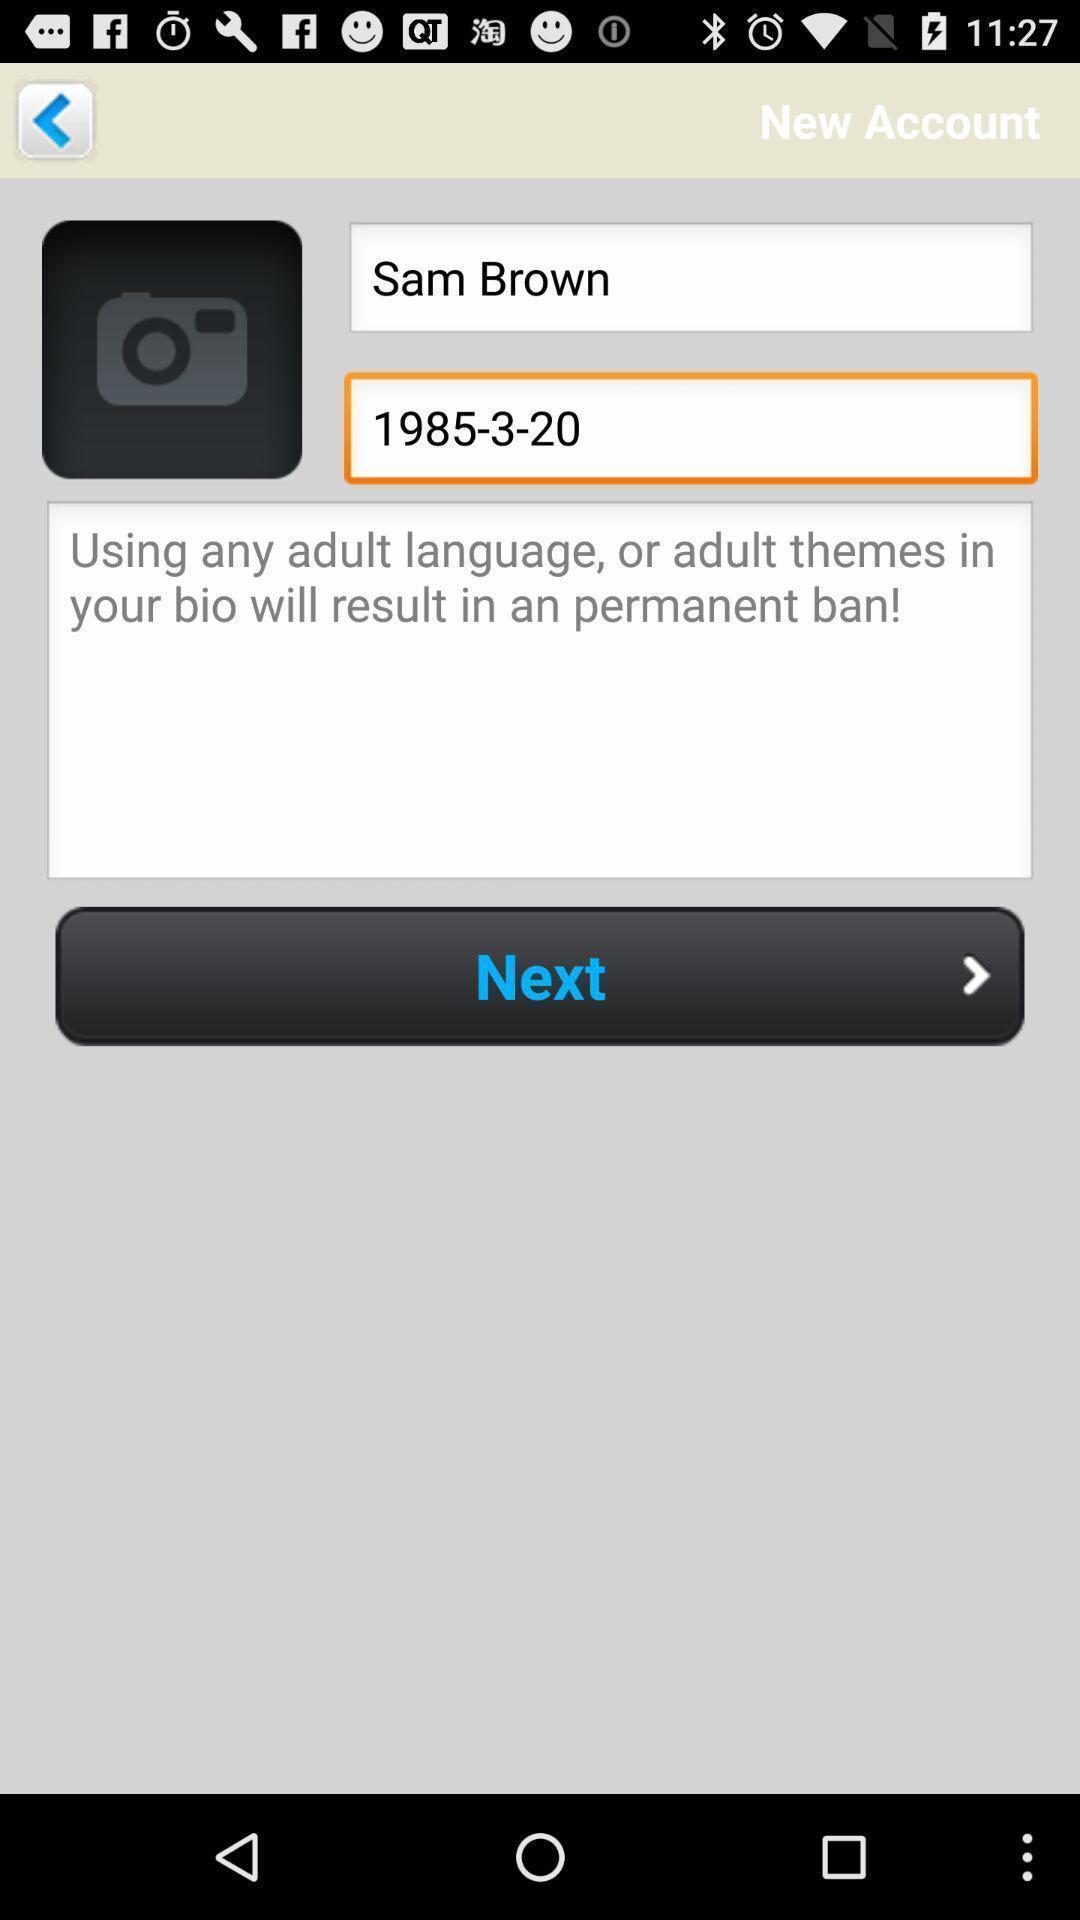Explain what's happening in this screen capture. Page showing the profile details. 